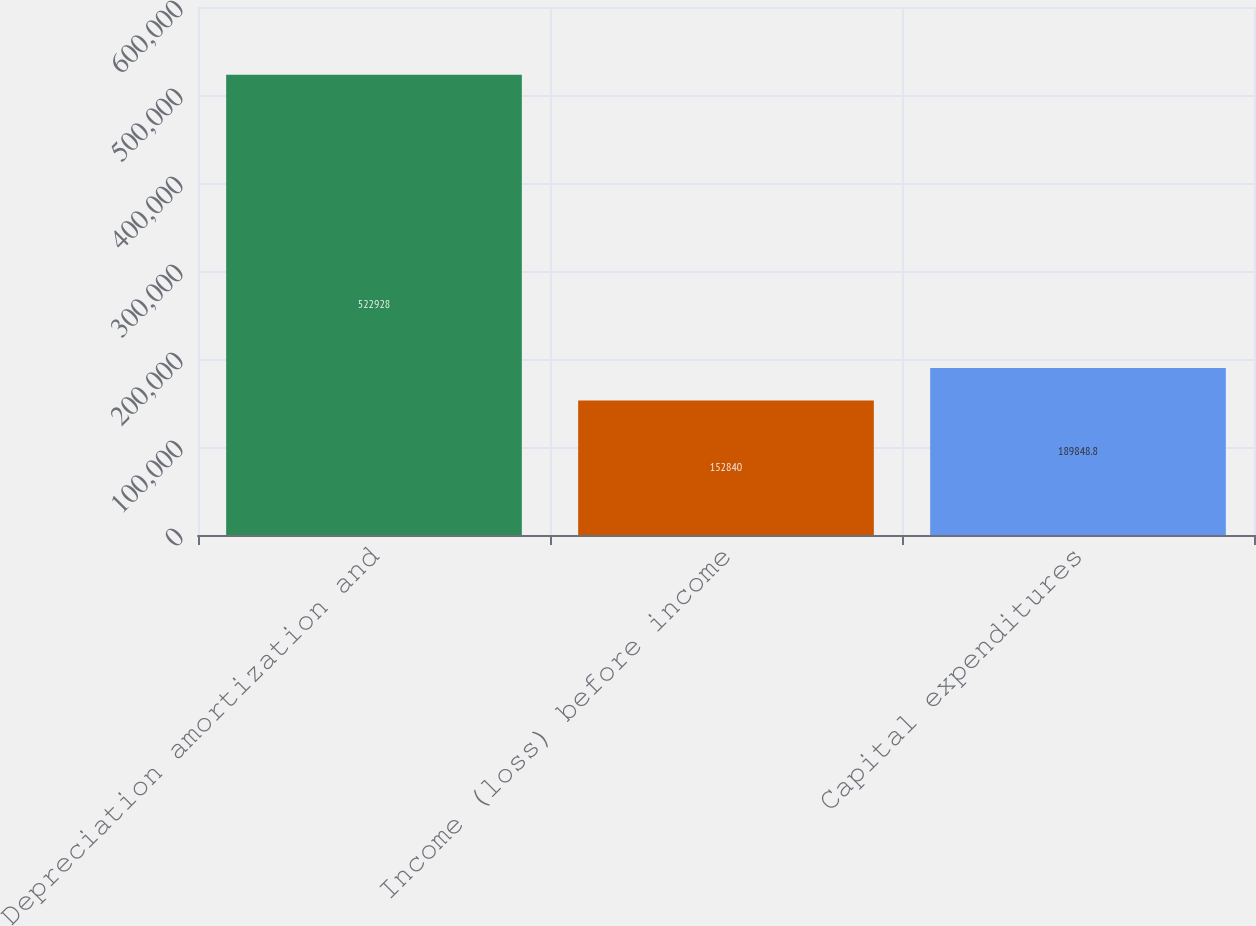Convert chart to OTSL. <chart><loc_0><loc_0><loc_500><loc_500><bar_chart><fcel>Depreciation amortization and<fcel>Income (loss) before income<fcel>Capital expenditures<nl><fcel>522928<fcel>152840<fcel>189849<nl></chart> 